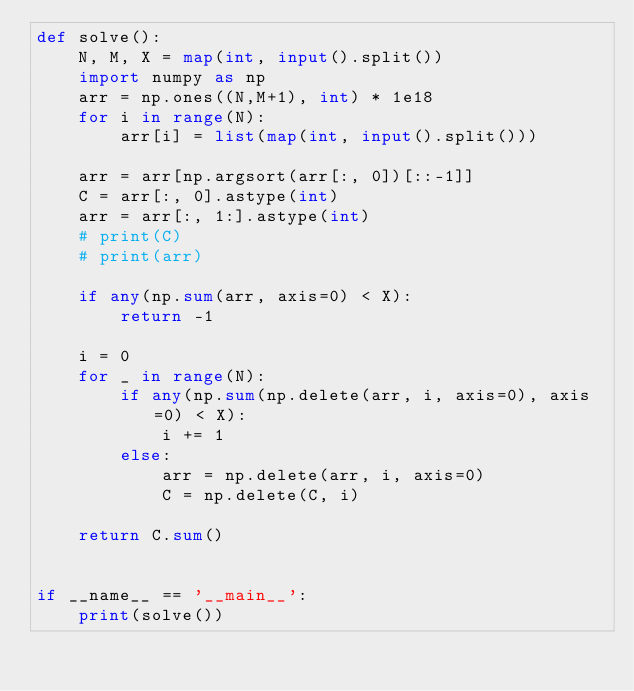Convert code to text. <code><loc_0><loc_0><loc_500><loc_500><_Python_>def solve():
    N, M, X = map(int, input().split()) 
    import numpy as np
    arr = np.ones((N,M+1), int) * 1e18
    for i in range(N):
        arr[i] = list(map(int, input().split()))
    
    arr = arr[np.argsort(arr[:, 0])[::-1]]
    C = arr[:, 0].astype(int)
    arr = arr[:, 1:].astype(int)
    # print(C)
    # print(arr)

    if any(np.sum(arr, axis=0) < X):
        return -1

    i = 0
    for _ in range(N):
        if any(np.sum(np.delete(arr, i, axis=0), axis=0) < X):
            i += 1
        else:
            arr = np.delete(arr, i, axis=0)
            C = np.delete(C, i)

    return C.sum()


if __name__ == '__main__':
    print(solve())</code> 